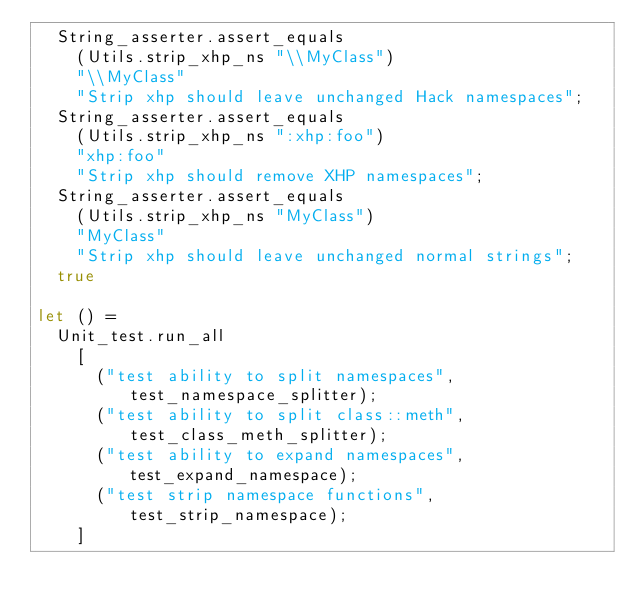<code> <loc_0><loc_0><loc_500><loc_500><_OCaml_>  String_asserter.assert_equals
    (Utils.strip_xhp_ns "\\MyClass")
    "\\MyClass"
    "Strip xhp should leave unchanged Hack namespaces";
  String_asserter.assert_equals
    (Utils.strip_xhp_ns ":xhp:foo")
    "xhp:foo"
    "Strip xhp should remove XHP namespaces";
  String_asserter.assert_equals
    (Utils.strip_xhp_ns "MyClass")
    "MyClass"
    "Strip xhp should leave unchanged normal strings";
  true

let () =
  Unit_test.run_all
    [
      ("test ability to split namespaces", test_namespace_splitter);
      ("test ability to split class::meth", test_class_meth_splitter);
      ("test ability to expand namespaces", test_expand_namespace);
      ("test strip namespace functions", test_strip_namespace);
    ]
</code> 